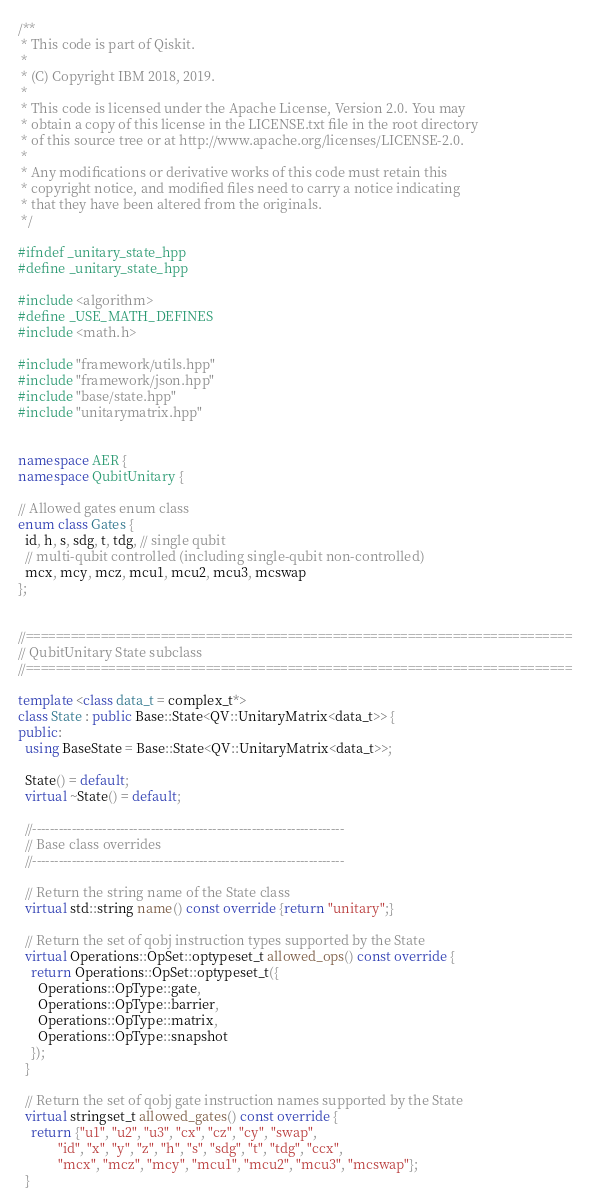Convert code to text. <code><loc_0><loc_0><loc_500><loc_500><_C++_>/**
 * This code is part of Qiskit.
 *
 * (C) Copyright IBM 2018, 2019.
 *
 * This code is licensed under the Apache License, Version 2.0. You may
 * obtain a copy of this license in the LICENSE.txt file in the root directory
 * of this source tree or at http://www.apache.org/licenses/LICENSE-2.0.
 *
 * Any modifications or derivative works of this code must retain this
 * copyright notice, and modified files need to carry a notice indicating
 * that they have been altered from the originals.
 */

#ifndef _unitary_state_hpp
#define _unitary_state_hpp

#include <algorithm>
#define _USE_MATH_DEFINES
#include <math.h>

#include "framework/utils.hpp"
#include "framework/json.hpp"
#include "base/state.hpp"
#include "unitarymatrix.hpp"


namespace AER {
namespace QubitUnitary {

// Allowed gates enum class
enum class Gates {
  id, h, s, sdg, t, tdg, // single qubit
  // multi-qubit controlled (including single-qubit non-controlled)
  mcx, mcy, mcz, mcu1, mcu2, mcu3, mcswap
};


//=========================================================================
// QubitUnitary State subclass
//=========================================================================

template <class data_t = complex_t*>
class State : public Base::State<QV::UnitaryMatrix<data_t>> {
public:
  using BaseState = Base::State<QV::UnitaryMatrix<data_t>>;

  State() = default;
  virtual ~State() = default;

  //-----------------------------------------------------------------------
  // Base class overrides
  //-----------------------------------------------------------------------

  // Return the string name of the State class
  virtual std::string name() const override {return "unitary";}

  // Return the set of qobj instruction types supported by the State
  virtual Operations::OpSet::optypeset_t allowed_ops() const override {
    return Operations::OpSet::optypeset_t({
      Operations::OpType::gate,
      Operations::OpType::barrier,
      Operations::OpType::matrix,
      Operations::OpType::snapshot
    });
  }

  // Return the set of qobj gate instruction names supported by the State
  virtual stringset_t allowed_gates() const override {
    return {"u1", "u2", "u3", "cx", "cz", "cy", "swap",
            "id", "x", "y", "z", "h", "s", "sdg", "t", "tdg", "ccx",
            "mcx", "mcz", "mcy", "mcu1", "mcu2", "mcu3", "mcswap"};
  }
</code> 